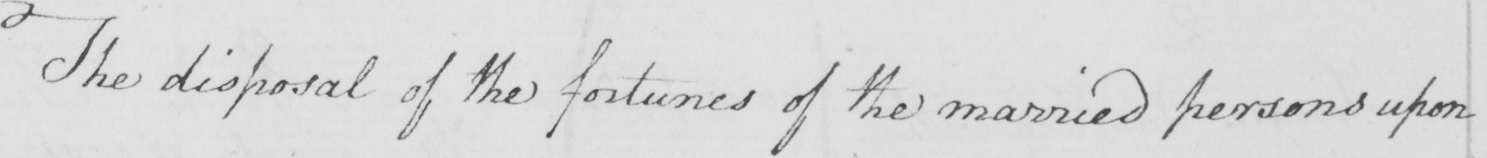What text is written in this handwritten line? The disposal of the fortunes of the married persons upon 